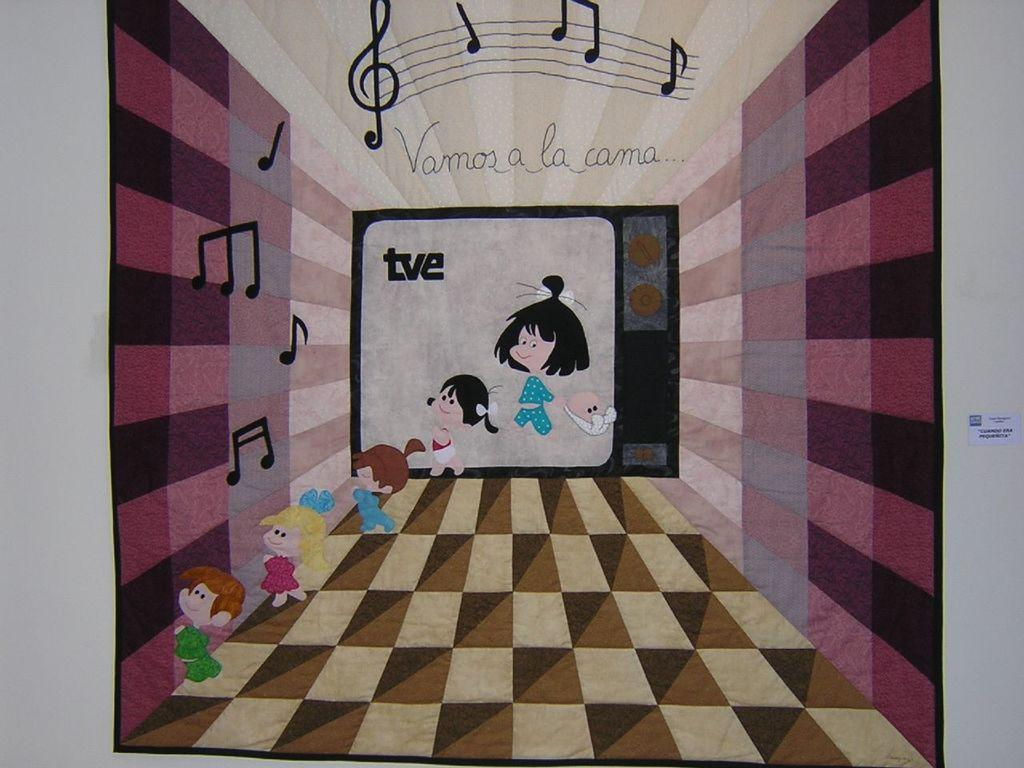<image>
Give a short and clear explanation of the subsequent image. A picture of  some kids coming out of a TV screen that says on top Vamos a la cama. 